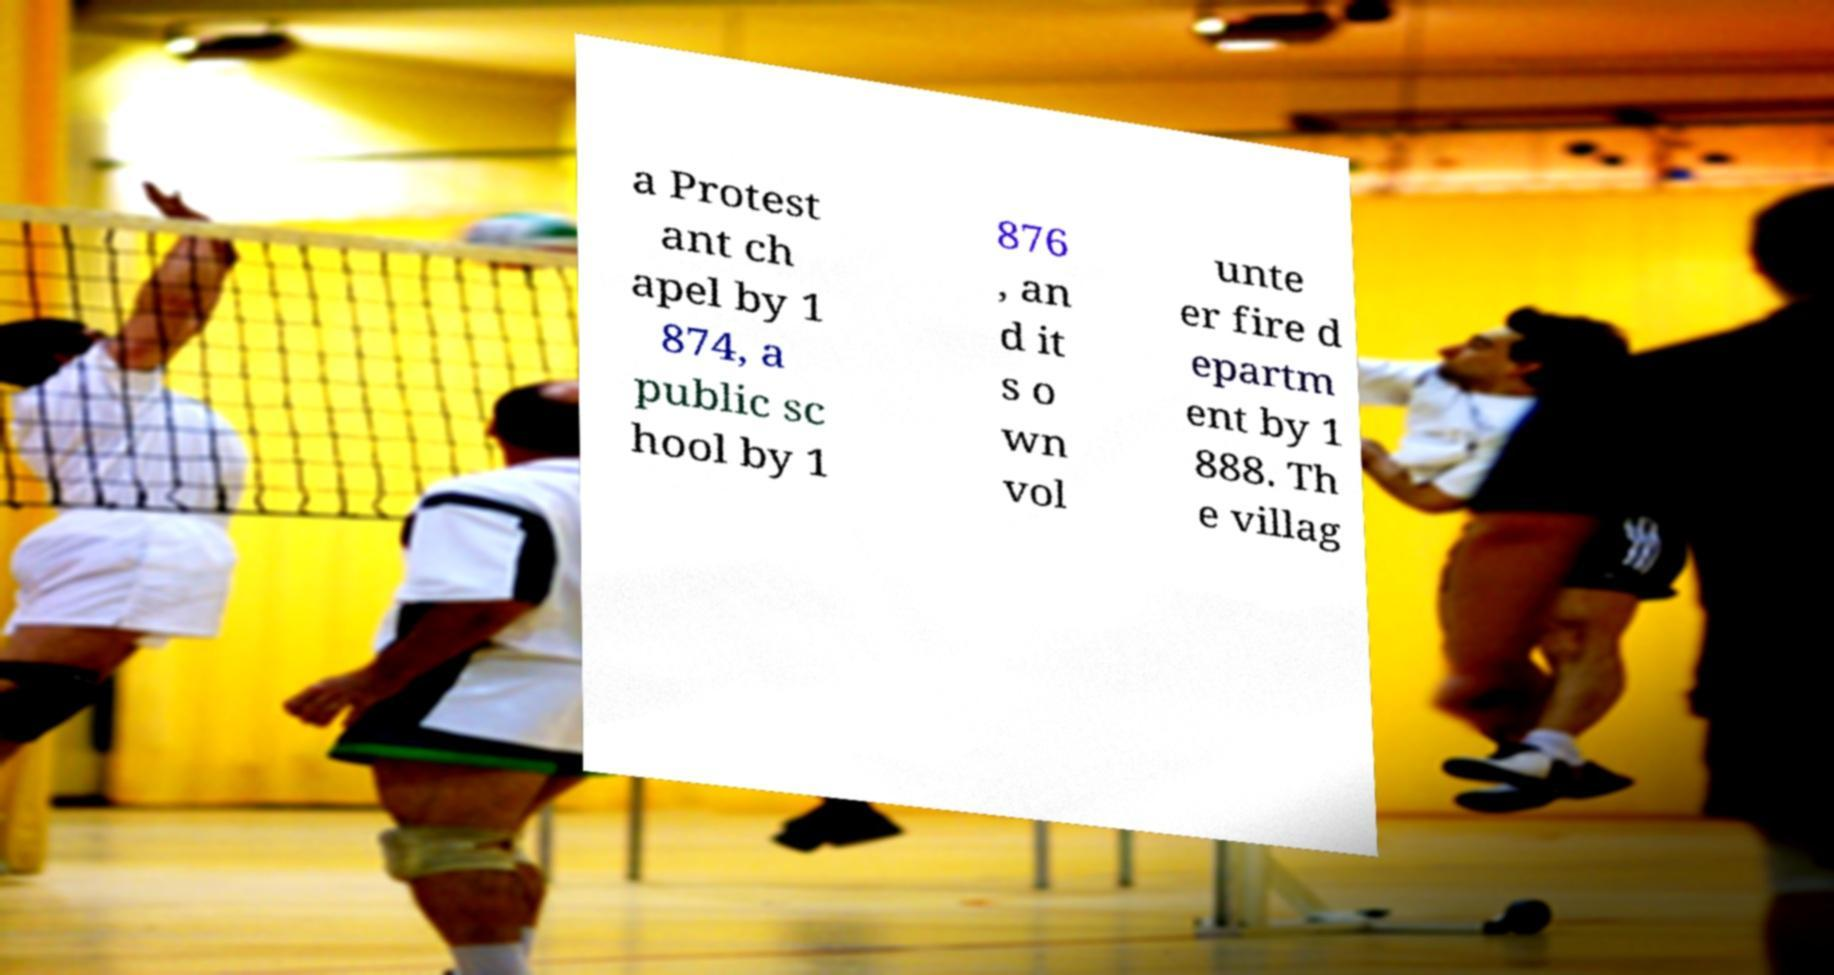For documentation purposes, I need the text within this image transcribed. Could you provide that? a Protest ant ch apel by 1 874, a public sc hool by 1 876 , an d it s o wn vol unte er fire d epartm ent by 1 888. Th e villag 